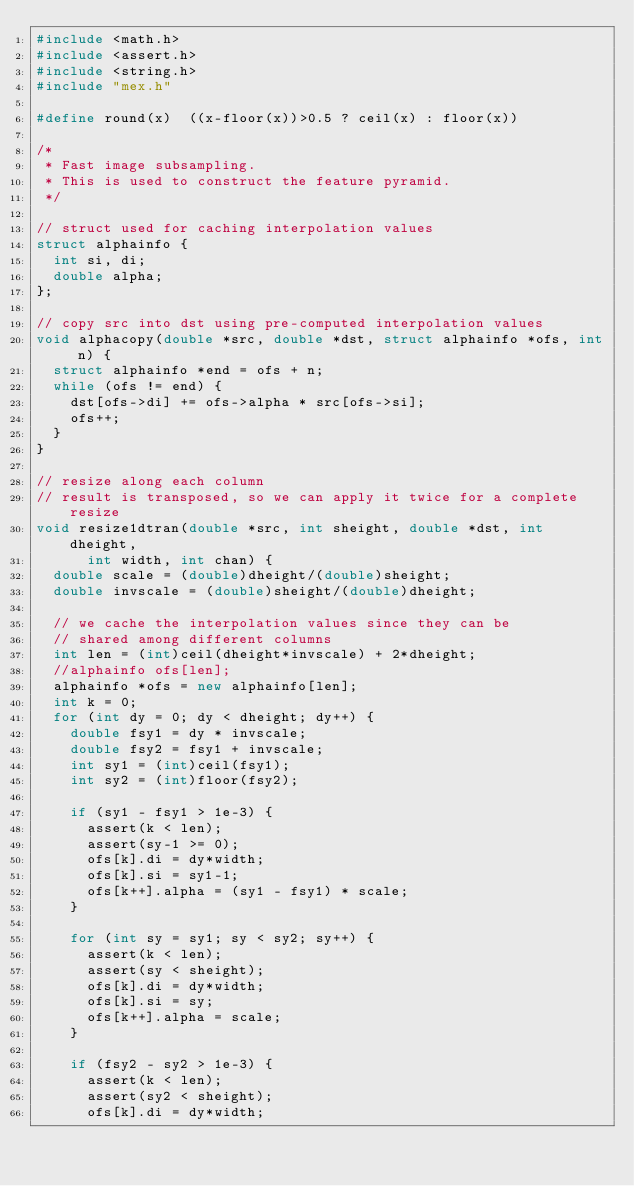<code> <loc_0><loc_0><loc_500><loc_500><_C++_>#include <math.h>
#include <assert.h>
#include <string.h>
#include "mex.h"

#define	round(x)	((x-floor(x))>0.5 ? ceil(x) : floor(x))

/*
 * Fast image subsampling.
 * This is used to construct the feature pyramid.
 */

// struct used for caching interpolation values
struct alphainfo {
  int si, di;
  double alpha;
};

// copy src into dst using pre-computed interpolation values
void alphacopy(double *src, double *dst, struct alphainfo *ofs, int n) {
  struct alphainfo *end = ofs + n;
  while (ofs != end) {
    dst[ofs->di] += ofs->alpha * src[ofs->si];
    ofs++;
  }
}

// resize along each column
// result is transposed, so we can apply it twice for a complete resize
void resize1dtran(double *src, int sheight, double *dst, int dheight, 
		  int width, int chan) {
  double scale = (double)dheight/(double)sheight;
  double invscale = (double)sheight/(double)dheight;
  
  // we cache the interpolation values since they can be 
  // shared among different columns
  int len = (int)ceil(dheight*invscale) + 2*dheight;
  //alphainfo ofs[len];
  alphainfo *ofs = new alphainfo[len];
  int k = 0;
  for (int dy = 0; dy < dheight; dy++) {
    double fsy1 = dy * invscale;
    double fsy2 = fsy1 + invscale;
    int sy1 = (int)ceil(fsy1);
    int sy2 = (int)floor(fsy2);       

    if (sy1 - fsy1 > 1e-3) {
      assert(k < len);
      assert(sy-1 >= 0);
      ofs[k].di = dy*width;
      ofs[k].si = sy1-1;
      ofs[k++].alpha = (sy1 - fsy1) * scale;
    }

    for (int sy = sy1; sy < sy2; sy++) {
      assert(k < len);
      assert(sy < sheight);
      ofs[k].di = dy*width;
      ofs[k].si = sy;
      ofs[k++].alpha = scale;
    }

    if (fsy2 - sy2 > 1e-3) {
      assert(k < len);
      assert(sy2 < sheight);
      ofs[k].di = dy*width;</code> 